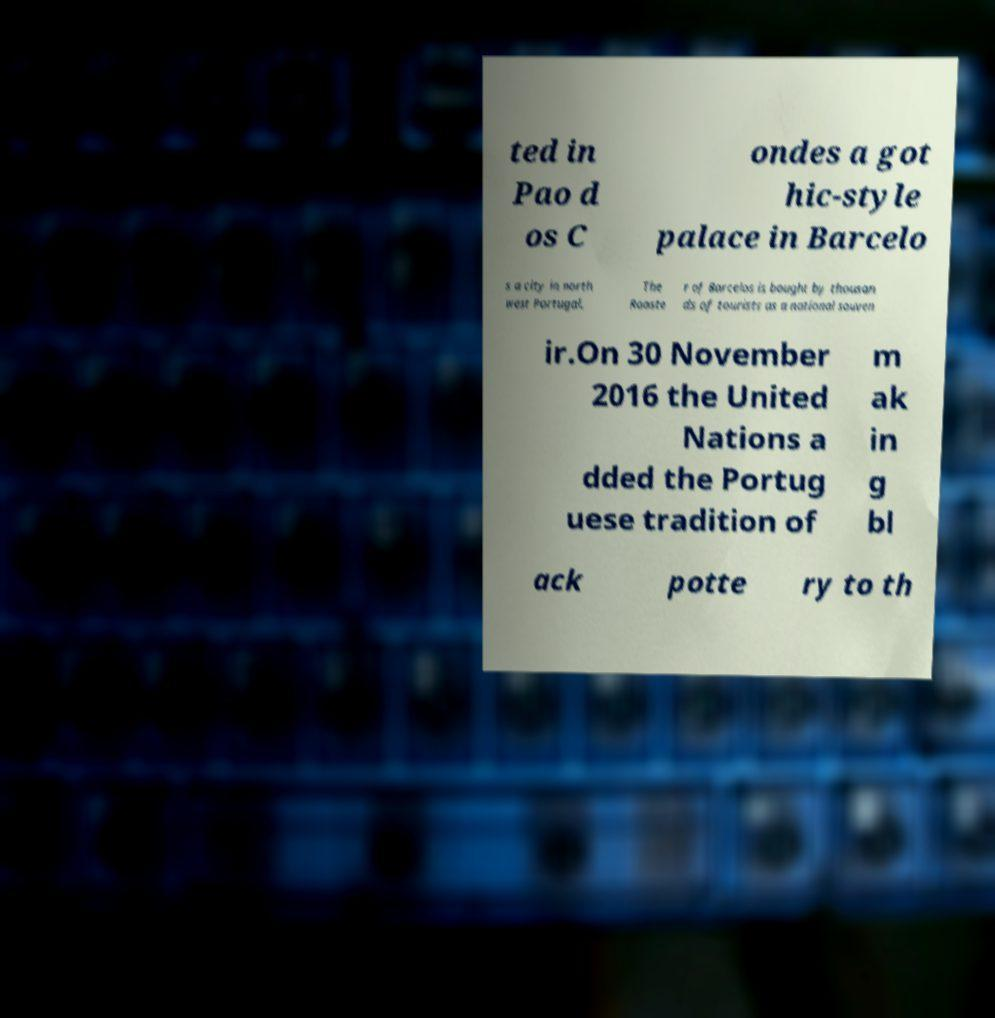Could you assist in decoding the text presented in this image and type it out clearly? ted in Pao d os C ondes a got hic-style palace in Barcelo s a city in north west Portugal. The Rooste r of Barcelos is bought by thousan ds of tourists as a national souven ir.On 30 November 2016 the United Nations a dded the Portug uese tradition of m ak in g bl ack potte ry to th 